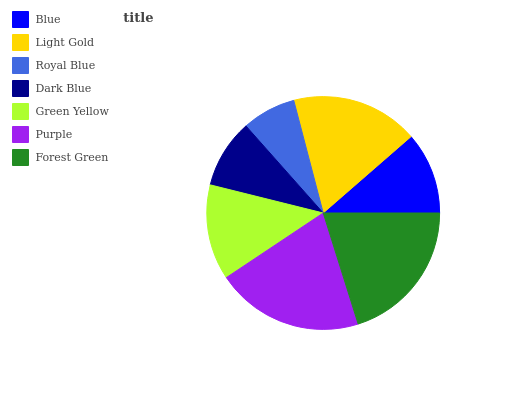Is Royal Blue the minimum?
Answer yes or no. Yes. Is Purple the maximum?
Answer yes or no. Yes. Is Light Gold the minimum?
Answer yes or no. No. Is Light Gold the maximum?
Answer yes or no. No. Is Light Gold greater than Blue?
Answer yes or no. Yes. Is Blue less than Light Gold?
Answer yes or no. Yes. Is Blue greater than Light Gold?
Answer yes or no. No. Is Light Gold less than Blue?
Answer yes or no. No. Is Green Yellow the high median?
Answer yes or no. Yes. Is Green Yellow the low median?
Answer yes or no. Yes. Is Forest Green the high median?
Answer yes or no. No. Is Forest Green the low median?
Answer yes or no. No. 